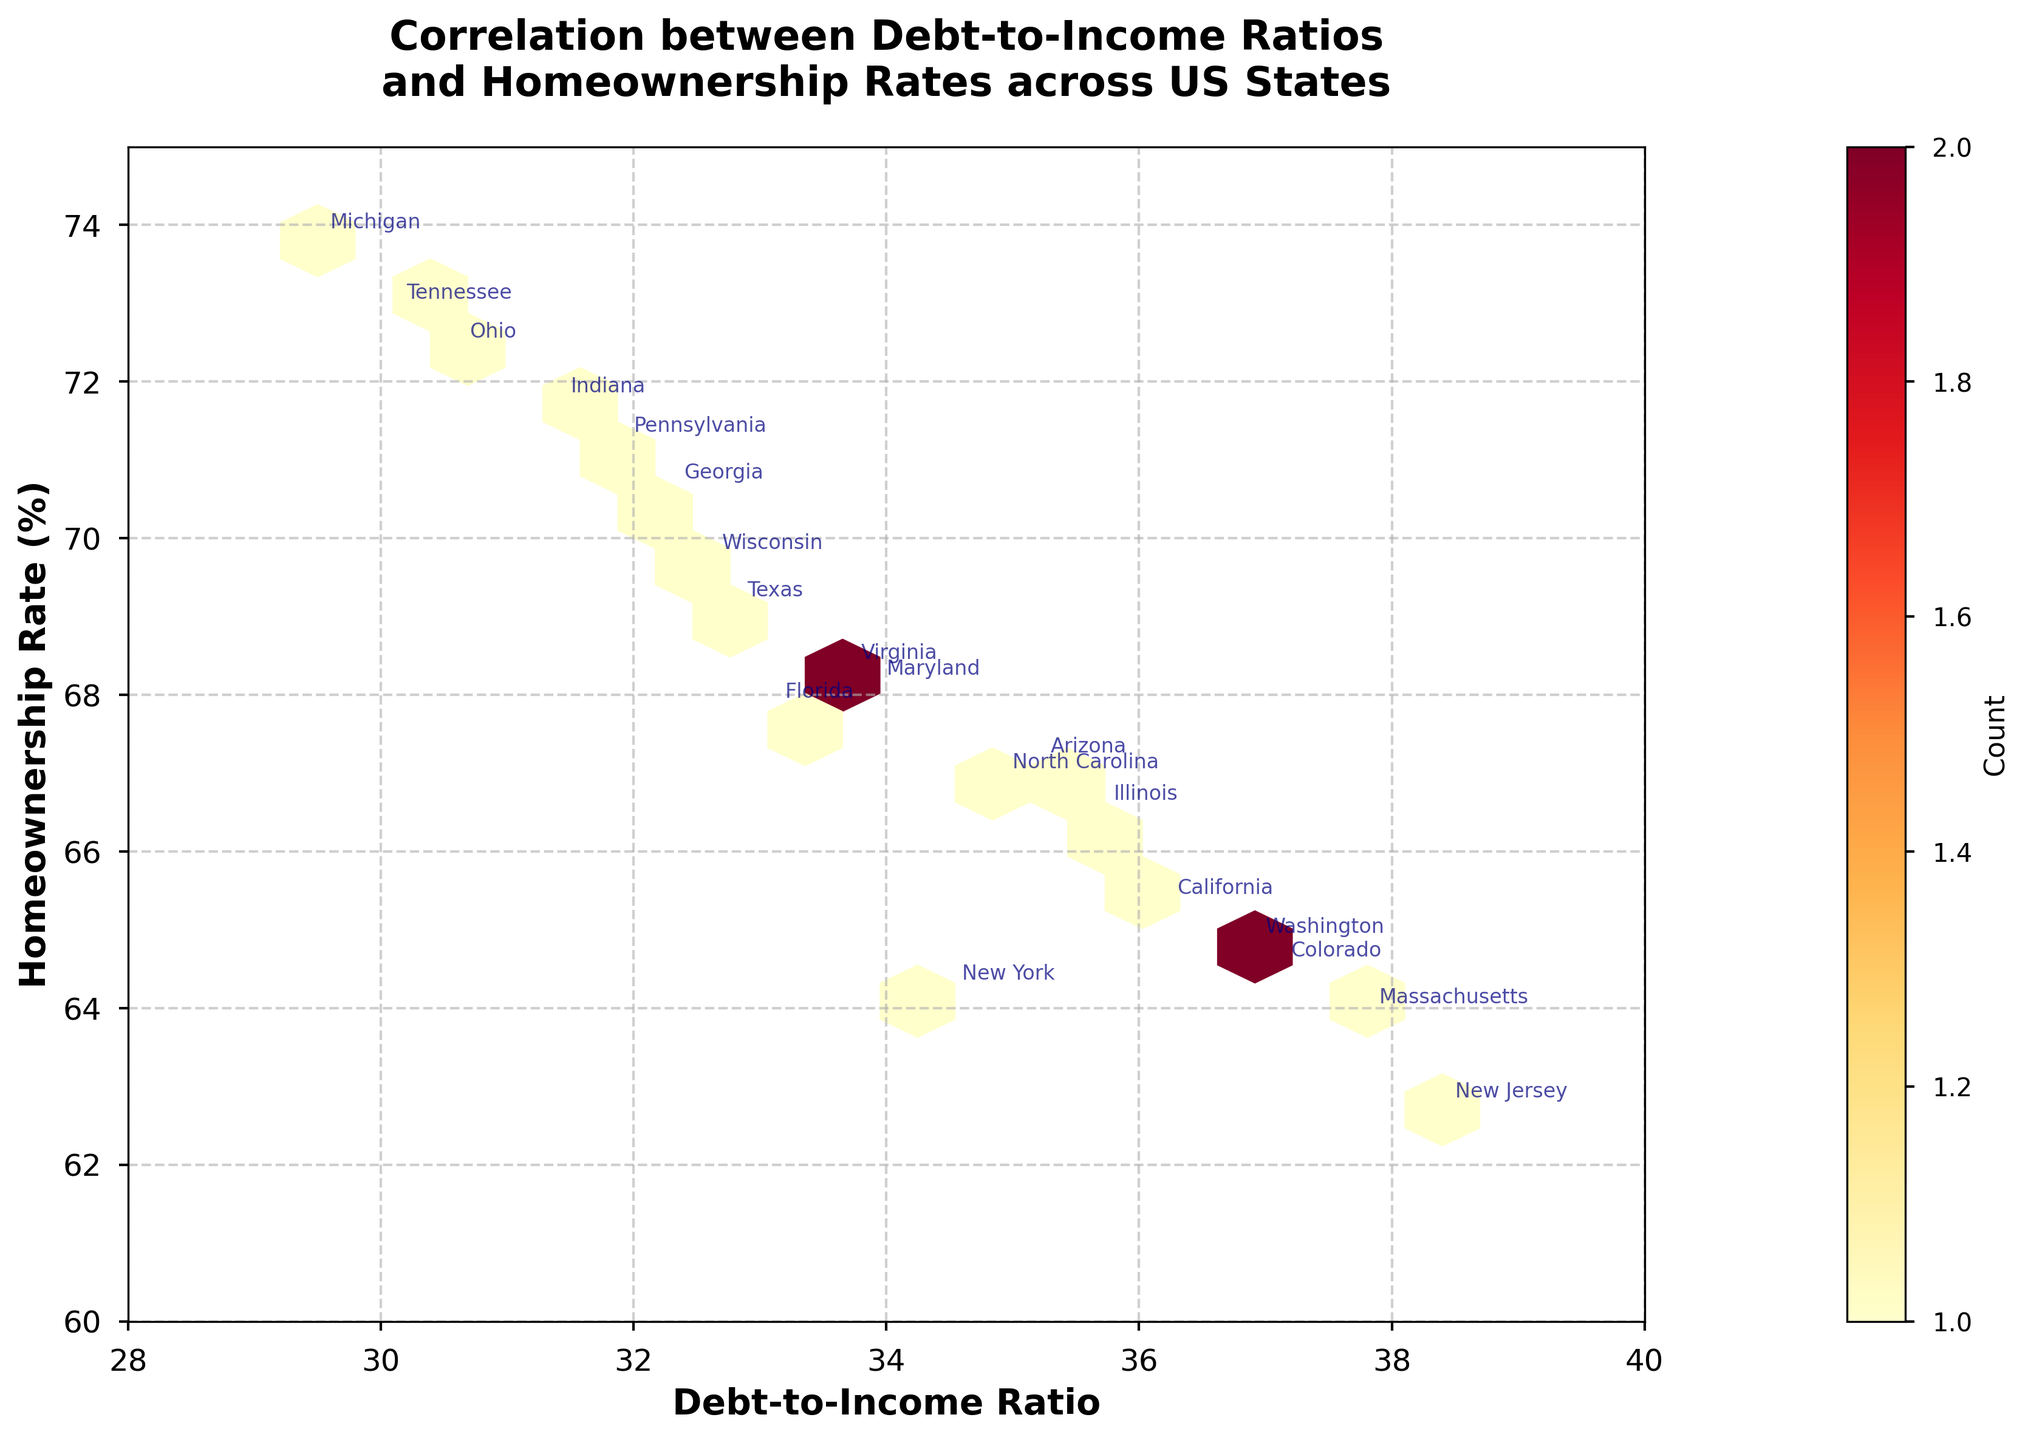how many data points are there in the plot? Each state is represented as a data point in the plot. By counting the number of states listed in the data provided, we can determine that there are 20 data points.
Answer: 20 what is the title of the plot? The title is prominently displayed at the top of the plot and reads 'Correlation between Debt-to-Income Ratios and Homeownership Rates across US States'.
Answer: Correlation between Debt-to-Income Ratios and Homeownership Rates across US States what does the color in the hexagonal bins represent? The color in the hexagonal bins represents the count of data points within each bin, with more intensive colors indicating higher counts.
Answer: count which state has the highest homeownership rate? By looking at the annotated homeownership rates along the y-axis, Michigan has the highest homeownership rate, depicted at approximately 73.8%.
Answer: Michigan are there any states with a debt-to-income ratio above 38? From the x-axis of the plot, New Jersey is the only state with a debt-to-income ratio above 38, specifically 38.4.
Answer: New Jersey what range of values is depicted on the y-axis? The y-axis of the plot, representing the homeownership rate, ranges from 60 to 75 (%).
Answer: 60 to 75 what is the general trend between debt-to-income ratio and homeownership rate based on the plot? By analyzing the spread and density of the hexagons, there appears to be an inverse correlation where states with higher debt-to-income ratios tend to have lower homeownership rates.
Answer: inverse correlation how many states have a debt-to-income ratio below 32 and homeownership rates above 70? By examining the annotated points on the plot, Ohio, Indiana, and Tennessee have debt-to-income ratios below 32 and homeownership rates above 70.
Answer: 3 states which states have homeownership rates between 68 and 70%? By looking at the y-axis and the annotated states, Texas and Maryland fall within the range of 68 to 70% homeownership rates.
Answer: Texas, Maryland 